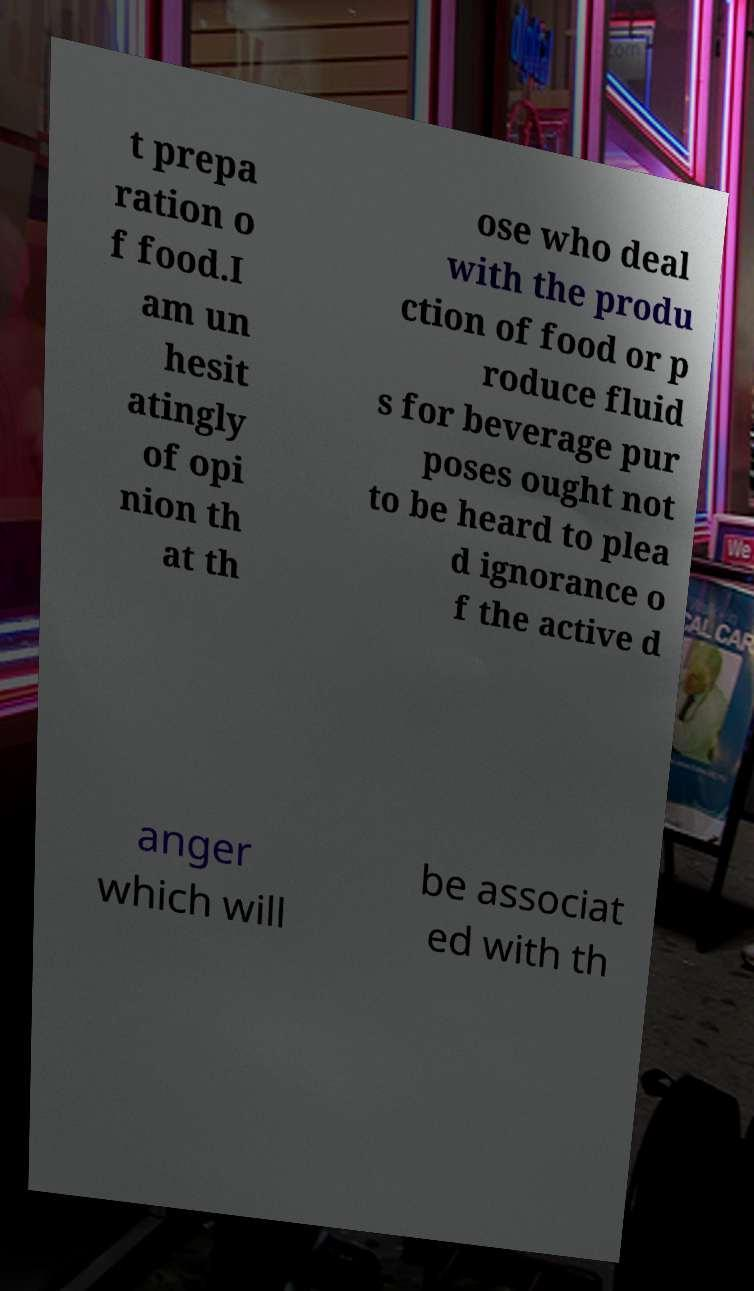There's text embedded in this image that I need extracted. Can you transcribe it verbatim? t prepa ration o f food.I am un hesit atingly of opi nion th at th ose who deal with the produ ction of food or p roduce fluid s for beverage pur poses ought not to be heard to plea d ignorance o f the active d anger which will be associat ed with th 